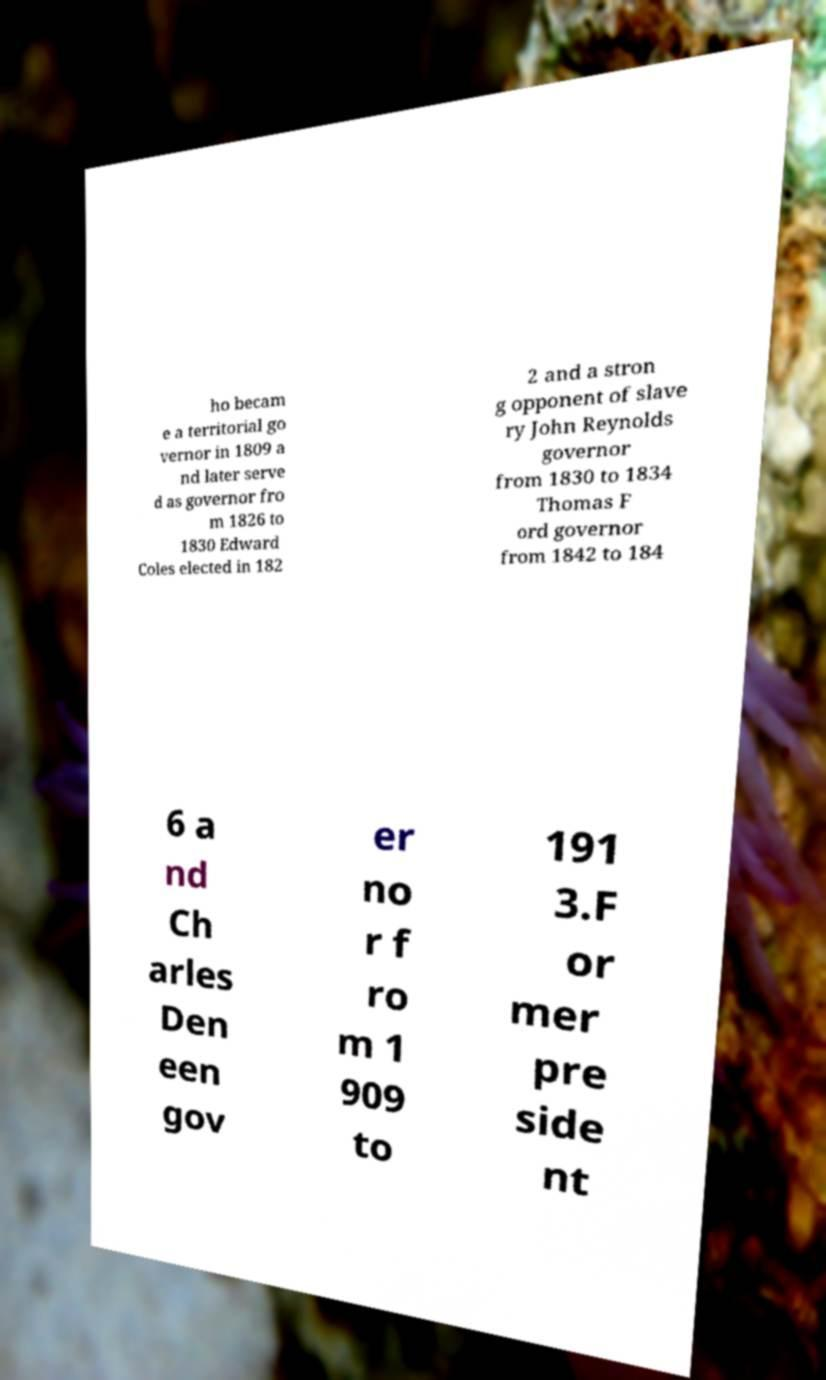Could you assist in decoding the text presented in this image and type it out clearly? ho becam e a territorial go vernor in 1809 a nd later serve d as governor fro m 1826 to 1830 Edward Coles elected in 182 2 and a stron g opponent of slave ry John Reynolds governor from 1830 to 1834 Thomas F ord governor from 1842 to 184 6 a nd Ch arles Den een gov er no r f ro m 1 909 to 191 3.F or mer pre side nt 